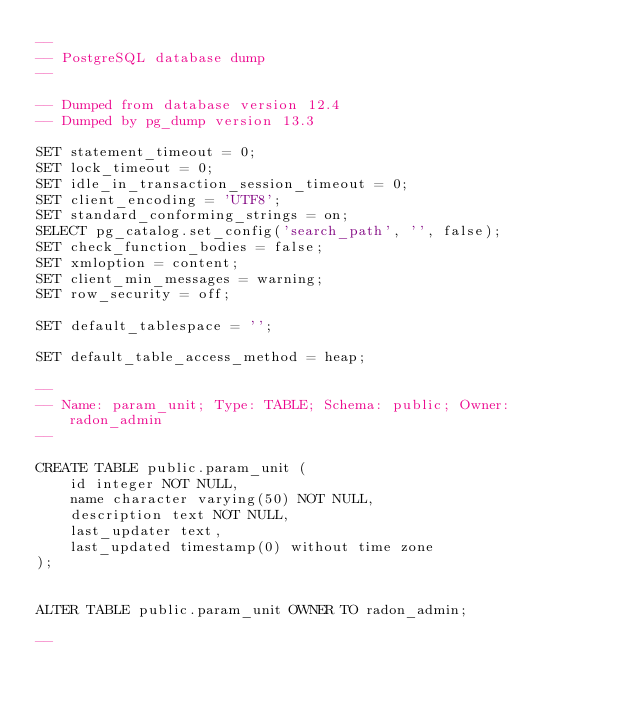<code> <loc_0><loc_0><loc_500><loc_500><_SQL_>--
-- PostgreSQL database dump
--

-- Dumped from database version 12.4
-- Dumped by pg_dump version 13.3

SET statement_timeout = 0;
SET lock_timeout = 0;
SET idle_in_transaction_session_timeout = 0;
SET client_encoding = 'UTF8';
SET standard_conforming_strings = on;
SELECT pg_catalog.set_config('search_path', '', false);
SET check_function_bodies = false;
SET xmloption = content;
SET client_min_messages = warning;
SET row_security = off;

SET default_tablespace = '';

SET default_table_access_method = heap;

--
-- Name: param_unit; Type: TABLE; Schema: public; Owner: radon_admin
--

CREATE TABLE public.param_unit (
    id integer NOT NULL,
    name character varying(50) NOT NULL,
    description text NOT NULL,
    last_updater text,
    last_updated timestamp(0) without time zone
);


ALTER TABLE public.param_unit OWNER TO radon_admin;

--</code> 